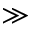<formula> <loc_0><loc_0><loc_500><loc_500>\gg</formula> 